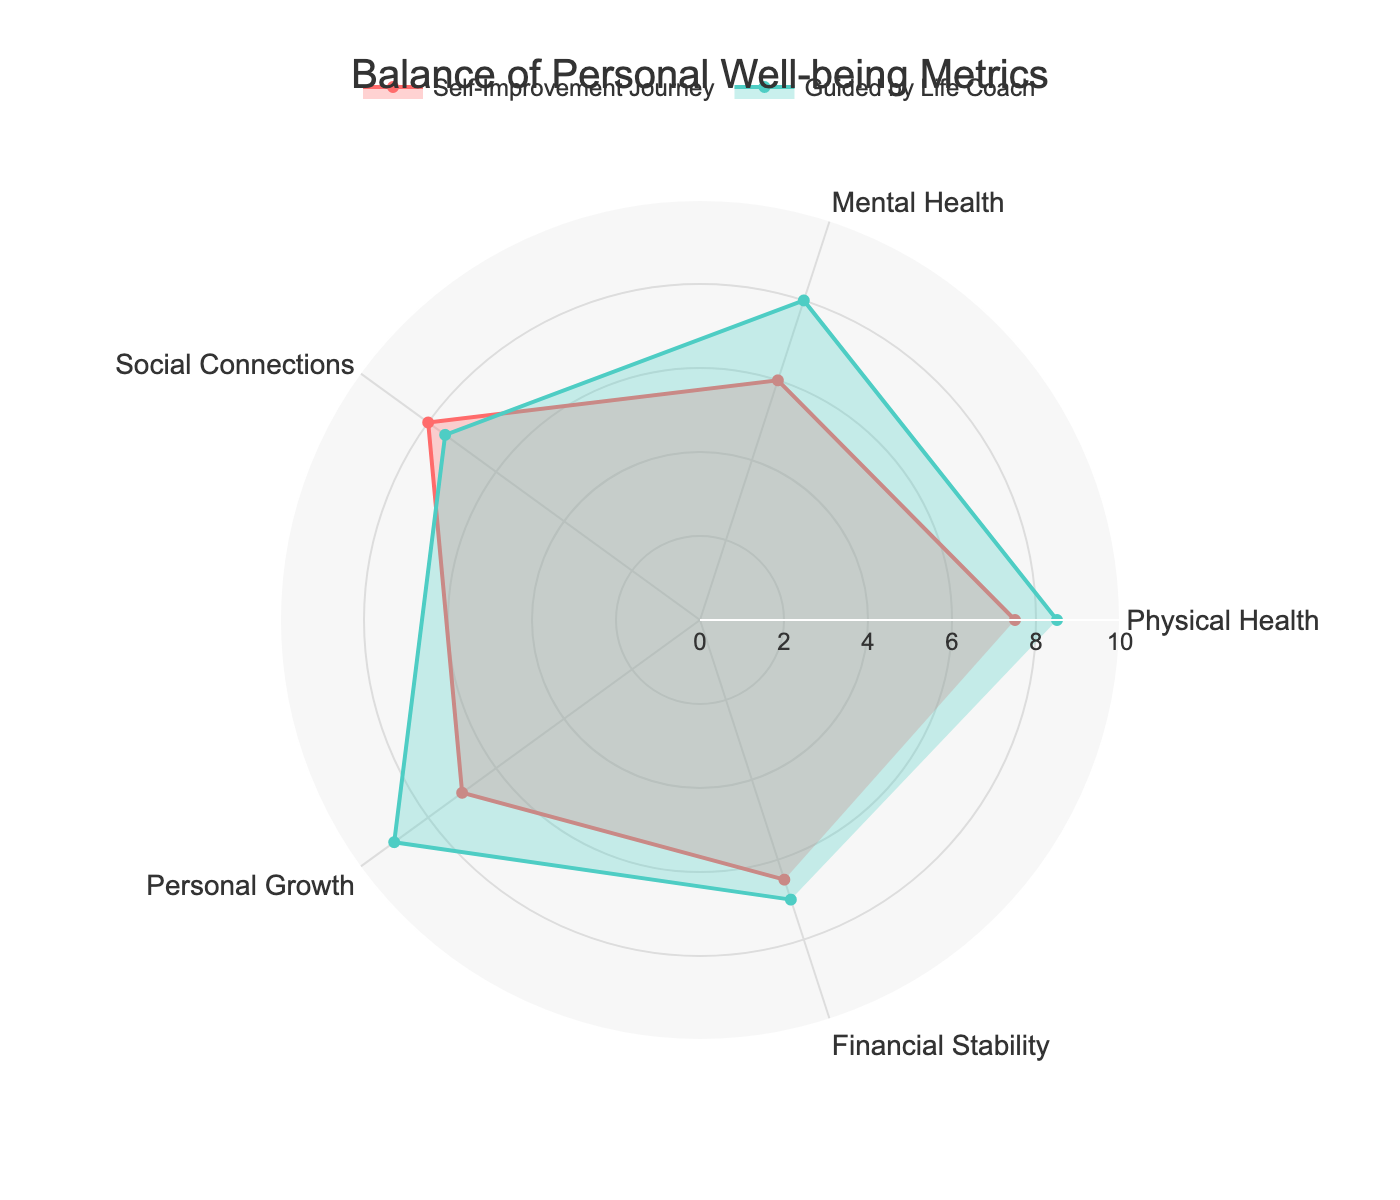What are the two categories with the highest scores for "Guided by Life Coach"? The highest scores for "Guided by Life Coach" can be identified by comparing the numerical values in each category. The two highest values are 9.0 in "Personal Growth" and 8.5 in "Physical Health".
Answer: Personal Growth and Physical Health How does the score for "Financial Stability" compare between "Self-Improvement Journey" and "Guided by Life Coach"? To compare scores, look at the "Financial Stability" values in both categories. The "Self-Improvement Journey" score is 6.5, and the "Guided by Life Coach" score is 7.0.
Answer: Guided by Life Coach is higher Which category shows the greatest improvement when guided by a life coach? Calculate the differences between the "Guided by Life Coach" and "Self-Improvement Journey" scores for each category, then identify the largest increase. For "Personal Growth", the difference is 9.0 - 7.0 = 2.0, which is the greatest improvement.
Answer: Personal Growth What is the average score across all categories for the "Self-Improvement Journey"? Sum the "Self-Improvement Journey" scores (7.5, 6.0, 8.0, 7.0, and 6.5) and divide by the number of categories, which is 5. Thus, (7.5 + 6.0 + 8.0 + 7.0 + 6.5) / 5 = 7.0.
Answer: 7.0 Which category scores differ the least between the two journeys? Calculate the absolute differences for each category between "Self-Improvement Journey" and "Guided by Life Coach". The smallest difference is for "Financial Stability" (7.0 - 6.5 = 0.5).
Answer: Financial Stability For which category did the "Self-Improvement Journey" score higher than "Guided by Life Coach"? Compare each category's scores. "Social Connections" is the only category where "Self-Improvement Journey" (8.0) is higher than "Guided by Life Coach" (7.5).
Answer: Social Connections What is the total score for all categories combined for "Guided by Life Coach"? Sum all the scores for "Guided by Life Coach": 8.5 + 8.0 + 7.5 + 9.0 + 7.0 = 40.0.
Answer: 40.0 Which category has the most balanced score between "Self-Improvement Journey" and "Guided by Life Coach"? Calculate the ratios of scores between the two journeys to find the one closest to 1. "Financial Stability" (7.0 / 6.5 ≈ 1.08) is the most balanced.
Answer: Financial Stability 